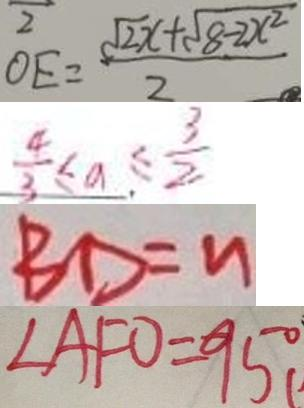Convert formula to latex. <formula><loc_0><loc_0><loc_500><loc_500>O E = \frac { \sqrt { 2 } x + \sqrt { 8 - 2 x ^ { 2 } } } { 2 } 
 \frac { 4 } { 3 } \leq a \leq \frac { 3 } { 2 } 
 B D = n 
 \angle A F O = 9 5 ^ { \circ }</formula> 